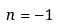Convert formula to latex. <formula><loc_0><loc_0><loc_500><loc_500>n = - 1</formula> 